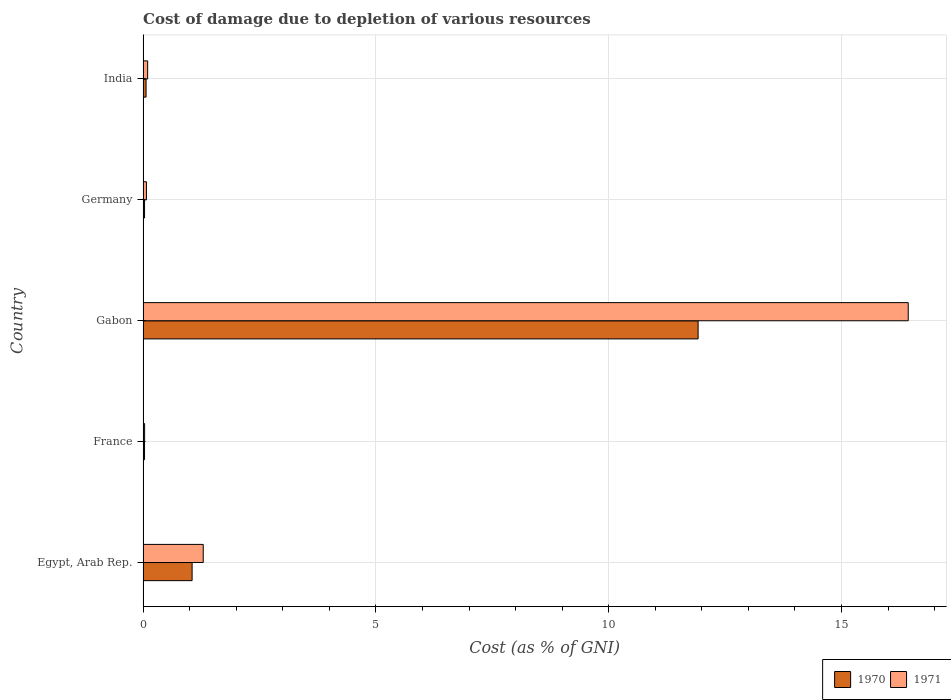Are the number of bars on each tick of the Y-axis equal?
Offer a very short reply. Yes. What is the label of the 4th group of bars from the top?
Your answer should be very brief. France. What is the cost of damage caused due to the depletion of various resources in 1971 in India?
Your response must be concise. 0.1. Across all countries, what is the maximum cost of damage caused due to the depletion of various resources in 1970?
Give a very brief answer. 11.92. Across all countries, what is the minimum cost of damage caused due to the depletion of various resources in 1971?
Make the answer very short. 0.03. In which country was the cost of damage caused due to the depletion of various resources in 1971 maximum?
Give a very brief answer. Gabon. What is the total cost of damage caused due to the depletion of various resources in 1970 in the graph?
Give a very brief answer. 13.1. What is the difference between the cost of damage caused due to the depletion of various resources in 1970 in Egypt, Arab Rep. and that in Gabon?
Provide a succinct answer. -10.87. What is the difference between the cost of damage caused due to the depletion of various resources in 1971 in Egypt, Arab Rep. and the cost of damage caused due to the depletion of various resources in 1970 in France?
Offer a very short reply. 1.26. What is the average cost of damage caused due to the depletion of various resources in 1970 per country?
Make the answer very short. 2.62. What is the difference between the cost of damage caused due to the depletion of various resources in 1970 and cost of damage caused due to the depletion of various resources in 1971 in Egypt, Arab Rep.?
Your answer should be very brief. -0.24. What is the ratio of the cost of damage caused due to the depletion of various resources in 1971 in Gabon to that in India?
Offer a terse response. 166.63. Is the cost of damage caused due to the depletion of various resources in 1971 in Egypt, Arab Rep. less than that in India?
Provide a succinct answer. No. What is the difference between the highest and the second highest cost of damage caused due to the depletion of various resources in 1970?
Your response must be concise. 10.87. What is the difference between the highest and the lowest cost of damage caused due to the depletion of various resources in 1970?
Keep it short and to the point. 11.89. What does the 2nd bar from the top in France represents?
Offer a terse response. 1970. How many bars are there?
Provide a short and direct response. 10. How many countries are there in the graph?
Offer a terse response. 5. Does the graph contain grids?
Keep it short and to the point. Yes. What is the title of the graph?
Make the answer very short. Cost of damage due to depletion of various resources. What is the label or title of the X-axis?
Your answer should be compact. Cost (as % of GNI). What is the Cost (as % of GNI) of 1970 in Egypt, Arab Rep.?
Provide a short and direct response. 1.05. What is the Cost (as % of GNI) in 1971 in Egypt, Arab Rep.?
Offer a very short reply. 1.29. What is the Cost (as % of GNI) of 1970 in France?
Your response must be concise. 0.03. What is the Cost (as % of GNI) of 1971 in France?
Provide a short and direct response. 0.03. What is the Cost (as % of GNI) of 1970 in Gabon?
Keep it short and to the point. 11.92. What is the Cost (as % of GNI) in 1971 in Gabon?
Offer a very short reply. 16.43. What is the Cost (as % of GNI) in 1970 in Germany?
Offer a terse response. 0.03. What is the Cost (as % of GNI) in 1971 in Germany?
Offer a very short reply. 0.07. What is the Cost (as % of GNI) in 1970 in India?
Give a very brief answer. 0.06. What is the Cost (as % of GNI) in 1971 in India?
Offer a very short reply. 0.1. Across all countries, what is the maximum Cost (as % of GNI) in 1970?
Give a very brief answer. 11.92. Across all countries, what is the maximum Cost (as % of GNI) in 1971?
Make the answer very short. 16.43. Across all countries, what is the minimum Cost (as % of GNI) of 1970?
Your response must be concise. 0.03. Across all countries, what is the minimum Cost (as % of GNI) of 1971?
Your answer should be compact. 0.03. What is the total Cost (as % of GNI) in 1970 in the graph?
Your response must be concise. 13.1. What is the total Cost (as % of GNI) in 1971 in the graph?
Your answer should be very brief. 17.93. What is the difference between the Cost (as % of GNI) in 1970 in Egypt, Arab Rep. and that in France?
Ensure brevity in your answer.  1.02. What is the difference between the Cost (as % of GNI) of 1971 in Egypt, Arab Rep. and that in France?
Provide a succinct answer. 1.26. What is the difference between the Cost (as % of GNI) in 1970 in Egypt, Arab Rep. and that in Gabon?
Offer a very short reply. -10.87. What is the difference between the Cost (as % of GNI) in 1971 in Egypt, Arab Rep. and that in Gabon?
Provide a short and direct response. -15.14. What is the difference between the Cost (as % of GNI) of 1970 in Egypt, Arab Rep. and that in Germany?
Keep it short and to the point. 1.02. What is the difference between the Cost (as % of GNI) in 1971 in Egypt, Arab Rep. and that in Germany?
Give a very brief answer. 1.22. What is the difference between the Cost (as % of GNI) in 1970 in Egypt, Arab Rep. and that in India?
Keep it short and to the point. 0.99. What is the difference between the Cost (as % of GNI) of 1971 in Egypt, Arab Rep. and that in India?
Keep it short and to the point. 1.19. What is the difference between the Cost (as % of GNI) of 1970 in France and that in Gabon?
Offer a very short reply. -11.89. What is the difference between the Cost (as % of GNI) of 1971 in France and that in Gabon?
Offer a very short reply. -16.4. What is the difference between the Cost (as % of GNI) of 1970 in France and that in Germany?
Your response must be concise. -0. What is the difference between the Cost (as % of GNI) in 1971 in France and that in Germany?
Keep it short and to the point. -0.04. What is the difference between the Cost (as % of GNI) in 1970 in France and that in India?
Offer a very short reply. -0.03. What is the difference between the Cost (as % of GNI) in 1971 in France and that in India?
Provide a short and direct response. -0.07. What is the difference between the Cost (as % of GNI) of 1970 in Gabon and that in Germany?
Your answer should be very brief. 11.89. What is the difference between the Cost (as % of GNI) of 1971 in Gabon and that in Germany?
Keep it short and to the point. 16.36. What is the difference between the Cost (as % of GNI) in 1970 in Gabon and that in India?
Your response must be concise. 11.86. What is the difference between the Cost (as % of GNI) of 1971 in Gabon and that in India?
Make the answer very short. 16.33. What is the difference between the Cost (as % of GNI) in 1970 in Germany and that in India?
Keep it short and to the point. -0.03. What is the difference between the Cost (as % of GNI) of 1971 in Germany and that in India?
Provide a short and direct response. -0.03. What is the difference between the Cost (as % of GNI) of 1970 in Egypt, Arab Rep. and the Cost (as % of GNI) of 1971 in France?
Ensure brevity in your answer.  1.02. What is the difference between the Cost (as % of GNI) of 1970 in Egypt, Arab Rep. and the Cost (as % of GNI) of 1971 in Gabon?
Your answer should be very brief. -15.38. What is the difference between the Cost (as % of GNI) in 1970 in Egypt, Arab Rep. and the Cost (as % of GNI) in 1971 in Germany?
Offer a very short reply. 0.98. What is the difference between the Cost (as % of GNI) in 1970 in Egypt, Arab Rep. and the Cost (as % of GNI) in 1971 in India?
Give a very brief answer. 0.95. What is the difference between the Cost (as % of GNI) of 1970 in France and the Cost (as % of GNI) of 1971 in Gabon?
Your answer should be compact. -16.4. What is the difference between the Cost (as % of GNI) in 1970 in France and the Cost (as % of GNI) in 1971 in Germany?
Keep it short and to the point. -0.04. What is the difference between the Cost (as % of GNI) of 1970 in France and the Cost (as % of GNI) of 1971 in India?
Your answer should be compact. -0.07. What is the difference between the Cost (as % of GNI) in 1970 in Gabon and the Cost (as % of GNI) in 1971 in Germany?
Ensure brevity in your answer.  11.85. What is the difference between the Cost (as % of GNI) in 1970 in Gabon and the Cost (as % of GNI) in 1971 in India?
Ensure brevity in your answer.  11.82. What is the difference between the Cost (as % of GNI) of 1970 in Germany and the Cost (as % of GNI) of 1971 in India?
Your answer should be very brief. -0.07. What is the average Cost (as % of GNI) of 1970 per country?
Keep it short and to the point. 2.62. What is the average Cost (as % of GNI) of 1971 per country?
Make the answer very short. 3.59. What is the difference between the Cost (as % of GNI) of 1970 and Cost (as % of GNI) of 1971 in Egypt, Arab Rep.?
Ensure brevity in your answer.  -0.24. What is the difference between the Cost (as % of GNI) in 1970 and Cost (as % of GNI) in 1971 in France?
Make the answer very short. -0. What is the difference between the Cost (as % of GNI) in 1970 and Cost (as % of GNI) in 1971 in Gabon?
Offer a very short reply. -4.51. What is the difference between the Cost (as % of GNI) of 1970 and Cost (as % of GNI) of 1971 in Germany?
Give a very brief answer. -0.04. What is the difference between the Cost (as % of GNI) in 1970 and Cost (as % of GNI) in 1971 in India?
Your answer should be compact. -0.03. What is the ratio of the Cost (as % of GNI) of 1970 in Egypt, Arab Rep. to that in France?
Keep it short and to the point. 33.37. What is the ratio of the Cost (as % of GNI) of 1971 in Egypt, Arab Rep. to that in France?
Ensure brevity in your answer.  38.77. What is the ratio of the Cost (as % of GNI) in 1970 in Egypt, Arab Rep. to that in Gabon?
Offer a very short reply. 0.09. What is the ratio of the Cost (as % of GNI) of 1971 in Egypt, Arab Rep. to that in Gabon?
Provide a succinct answer. 0.08. What is the ratio of the Cost (as % of GNI) of 1970 in Egypt, Arab Rep. to that in Germany?
Provide a succinct answer. 32.93. What is the ratio of the Cost (as % of GNI) in 1971 in Egypt, Arab Rep. to that in Germany?
Offer a very short reply. 17.84. What is the ratio of the Cost (as % of GNI) in 1970 in Egypt, Arab Rep. to that in India?
Offer a terse response. 16.34. What is the ratio of the Cost (as % of GNI) of 1971 in Egypt, Arab Rep. to that in India?
Ensure brevity in your answer.  13.1. What is the ratio of the Cost (as % of GNI) of 1970 in France to that in Gabon?
Provide a succinct answer. 0. What is the ratio of the Cost (as % of GNI) in 1971 in France to that in Gabon?
Keep it short and to the point. 0. What is the ratio of the Cost (as % of GNI) in 1970 in France to that in Germany?
Offer a very short reply. 0.99. What is the ratio of the Cost (as % of GNI) in 1971 in France to that in Germany?
Your response must be concise. 0.46. What is the ratio of the Cost (as % of GNI) of 1970 in France to that in India?
Offer a terse response. 0.49. What is the ratio of the Cost (as % of GNI) in 1971 in France to that in India?
Ensure brevity in your answer.  0.34. What is the ratio of the Cost (as % of GNI) of 1970 in Gabon to that in Germany?
Keep it short and to the point. 372.66. What is the ratio of the Cost (as % of GNI) in 1971 in Gabon to that in Germany?
Make the answer very short. 226.83. What is the ratio of the Cost (as % of GNI) of 1970 in Gabon to that in India?
Give a very brief answer. 184.89. What is the ratio of the Cost (as % of GNI) in 1971 in Gabon to that in India?
Make the answer very short. 166.63. What is the ratio of the Cost (as % of GNI) in 1970 in Germany to that in India?
Offer a very short reply. 0.5. What is the ratio of the Cost (as % of GNI) in 1971 in Germany to that in India?
Offer a very short reply. 0.73. What is the difference between the highest and the second highest Cost (as % of GNI) in 1970?
Make the answer very short. 10.87. What is the difference between the highest and the second highest Cost (as % of GNI) in 1971?
Offer a very short reply. 15.14. What is the difference between the highest and the lowest Cost (as % of GNI) in 1970?
Make the answer very short. 11.89. What is the difference between the highest and the lowest Cost (as % of GNI) of 1971?
Ensure brevity in your answer.  16.4. 